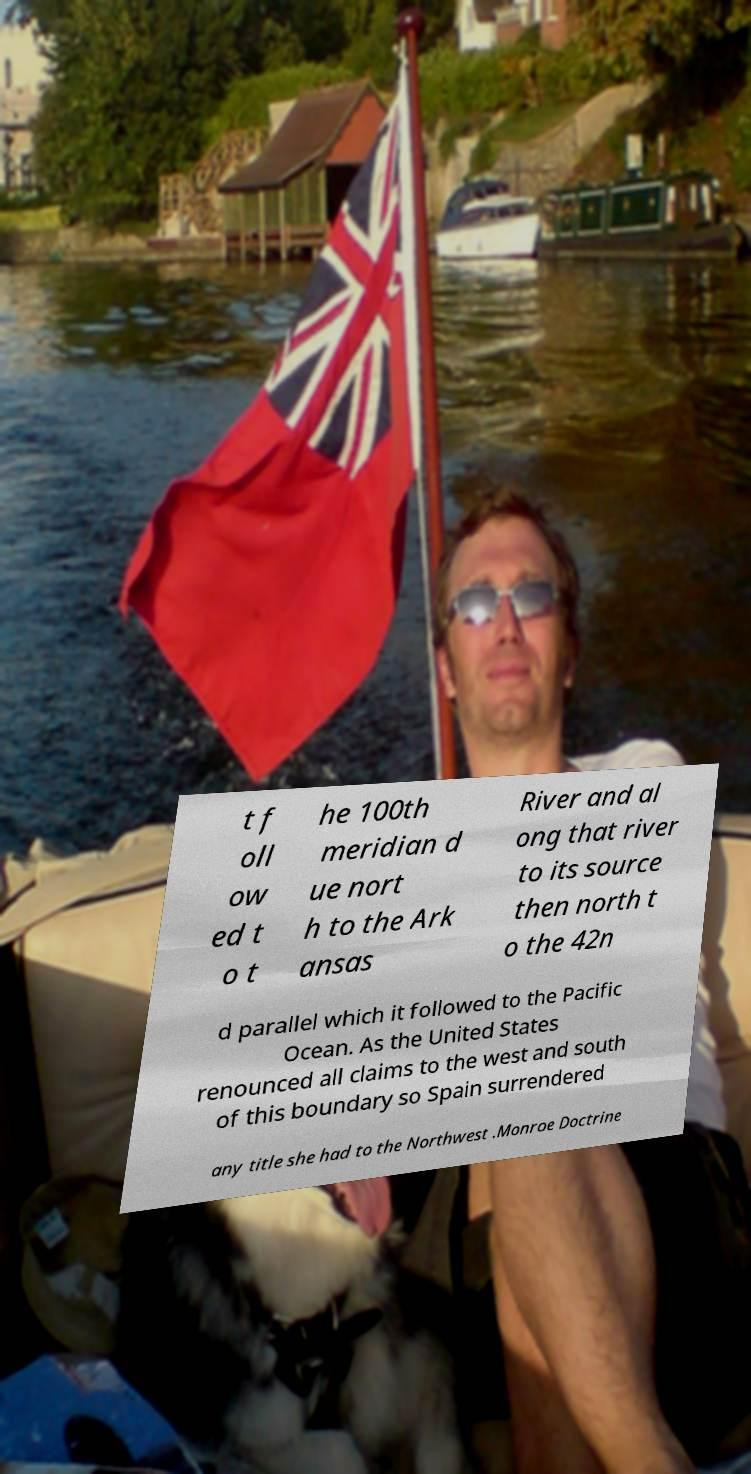Can you read and provide the text displayed in the image?This photo seems to have some interesting text. Can you extract and type it out for me? t f oll ow ed t o t he 100th meridian d ue nort h to the Ark ansas River and al ong that river to its source then north t o the 42n d parallel which it followed to the Pacific Ocean. As the United States renounced all claims to the west and south of this boundary so Spain surrendered any title she had to the Northwest .Monroe Doctrine 